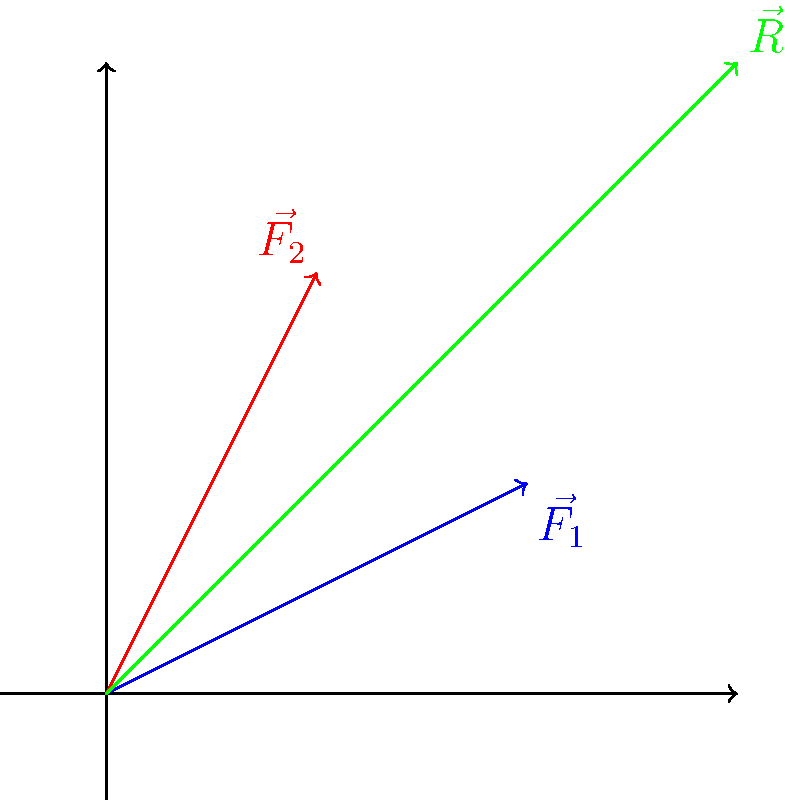In leather stitching, two forces $\vec{F_1}$ and $\vec{F_2}$ represent the tension in different directions of a particular stitch pattern. Given that $\vec{F_1} = 2\hat{i} + \hat{j}$ and $\vec{F_2} = \hat{i} + 2\hat{j}$ (in Newtons), calculate the magnitude of the resultant force $\vec{R}$ acting on the leather at this point. To solve this problem, we'll follow these steps:

1) First, we need to find the resultant vector $\vec{R}$. This is the sum of the two force vectors:
   $\vec{R} = \vec{F_1} + \vec{F_2}$

2) Let's add the vectors component-wise:
   $\vec{R} = (2\hat{i} + \hat{j}) + (\hat{i} + 2\hat{j})$
   $\vec{R} = (2+1)\hat{i} + (1+2)\hat{j}$
   $\vec{R} = 3\hat{i} + 3\hat{j}$

3) Now that we have the resultant vector, we need to find its magnitude. The magnitude of a vector is given by the square root of the sum of the squares of its components:
   $|\vec{R}| = \sqrt{(R_x)^2 + (R_y)^2}$

4) Substituting our values:
   $|\vec{R}| = \sqrt{3^2 + 3^2}$

5) Simplify:
   $|\vec{R}| = \sqrt{18}$

6) Simplify further:
   $|\vec{R}| = 3\sqrt{2}$ N

Thus, the magnitude of the resultant force is $3\sqrt{2}$ Newtons.
Answer: $3\sqrt{2}$ N 